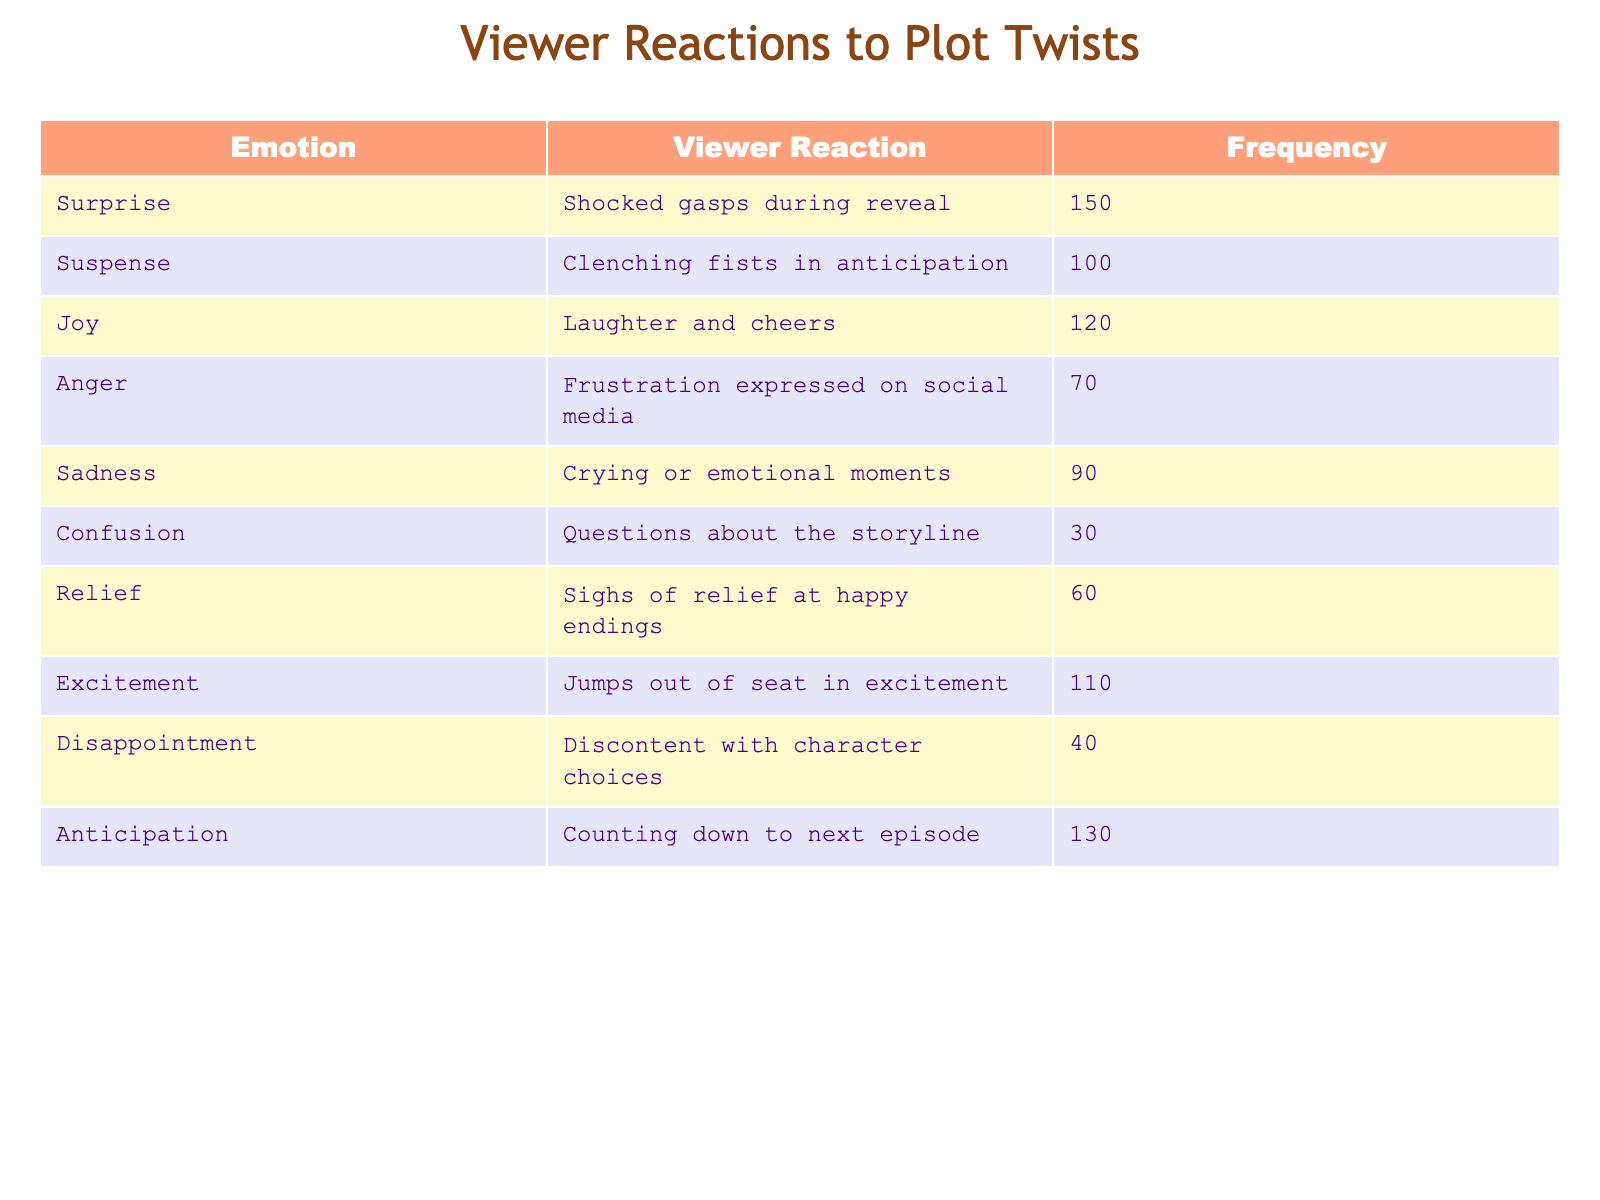What is the most frequent viewer reaction to plot twists? The most frequent viewer reaction is “Shocked gasps during reveal” with a frequency of 150, which is the highest value in the frequency column.
Answer: Shocked gasps during reveal How many viewers expressed joy through laughter and cheers? According to the table, 120 viewers reacted with joy through laughter and cheers, as indicated in the frequency column.
Answer: 120 What is the total frequency of viewer reactions categorized as negative emotions (anger, sadness, disappointment)? To find the total frequency of negative emotions, sum the frequencies: Anger (70) + Sadness (90) + Disappointment (40) = 200.
Answer: 200 Is the frequency of excitement greater than the frequency of confusion? Yes, the frequency of excitement is 110, while the frequency of confusion is only 30, so excitement is greater.
Answer: Yes What is the average frequency of all viewer reactions listed in the table? To calculate the average, sum all the frequencies: 150 + 100 + 120 + 70 + 90 + 30 + 60 + 110 + 40 + 130 = 1,000. There are 10 reactions, so the average frequency is 1,000 / 10 = 100.
Answer: 100 Which emotional response had the lowest viewer reaction, and what was its frequency? The emotional response with the lowest viewer reaction is “Questions about the storyline” with a frequency of 30, as seen in the table.
Answer: Questions about the storyline, 30 How many more viewers reacted with anticipation compared to those who felt relief? The frequency of anticipation is 130 and relief is 60. So, 130 - 60 = 70 more viewers reacted with anticipation.
Answer: 70 Which emotions had a frequency greater than 100, and how many are there? The emotions with frequencies greater than 100 are surprise (150), joy (120), anticipation (130), and excitement (110). There are four such emotions.
Answer: 4 Was the frequency of sadness greater than the frequency of anger? Yes, the frequency of sadness is 90, which is greater than anger's frequency of 70.
Answer: Yes 